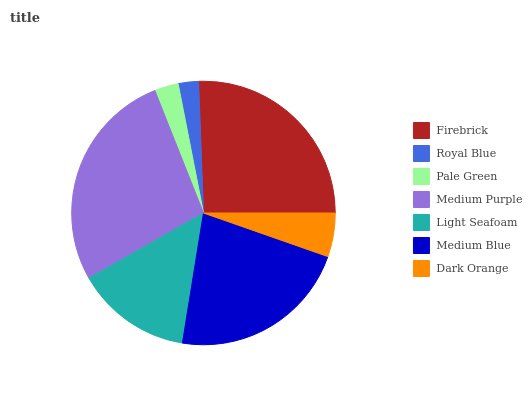Is Royal Blue the minimum?
Answer yes or no. Yes. Is Medium Purple the maximum?
Answer yes or no. Yes. Is Pale Green the minimum?
Answer yes or no. No. Is Pale Green the maximum?
Answer yes or no. No. Is Pale Green greater than Royal Blue?
Answer yes or no. Yes. Is Royal Blue less than Pale Green?
Answer yes or no. Yes. Is Royal Blue greater than Pale Green?
Answer yes or no. No. Is Pale Green less than Royal Blue?
Answer yes or no. No. Is Light Seafoam the high median?
Answer yes or no. Yes. Is Light Seafoam the low median?
Answer yes or no. Yes. Is Royal Blue the high median?
Answer yes or no. No. Is Medium Blue the low median?
Answer yes or no. No. 